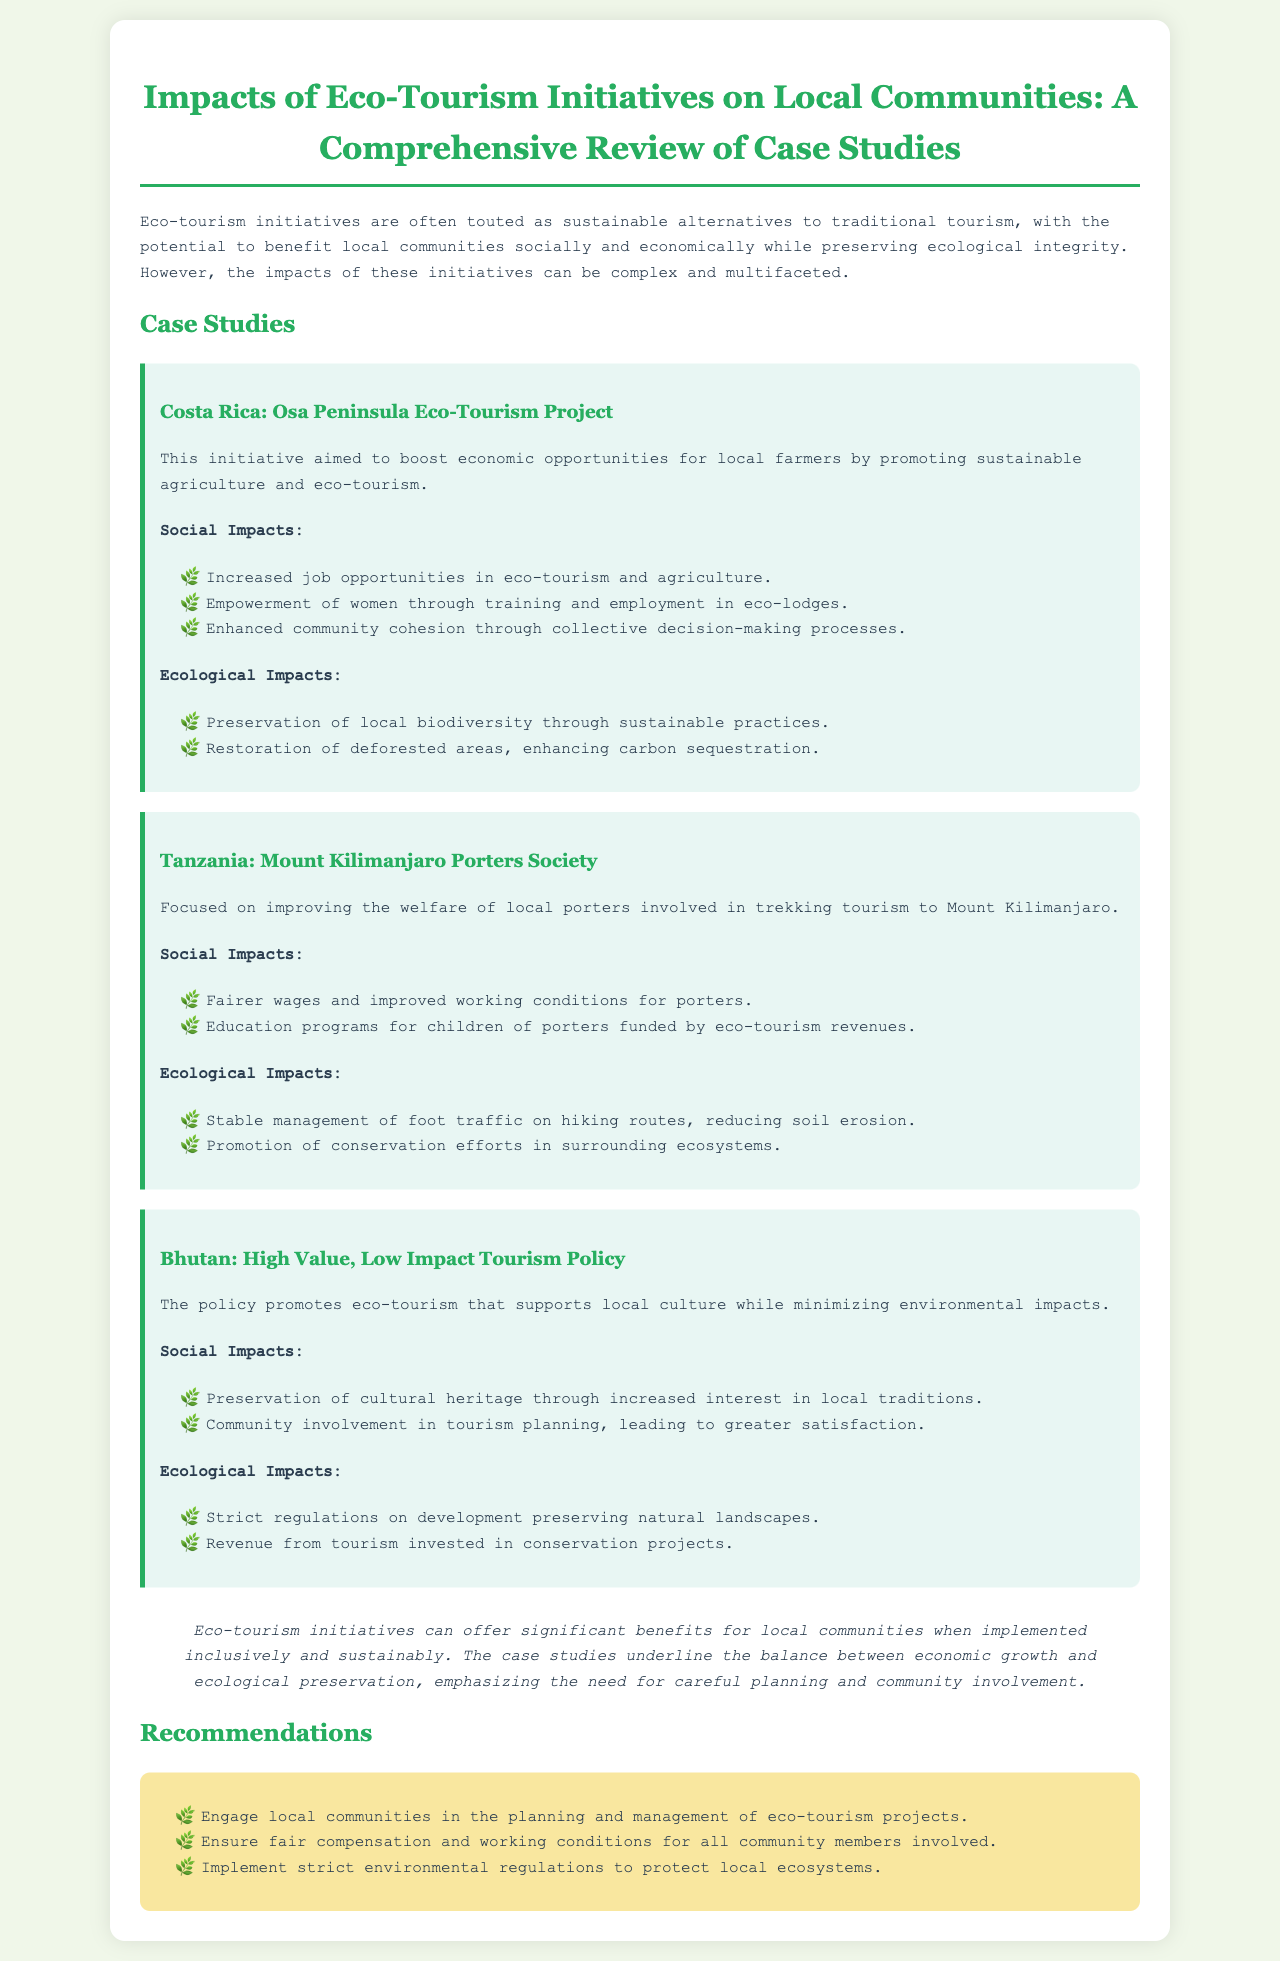what is the title of the report? The title of the report is highlighted at the top of the document, indicating the focus of the study.
Answer: Impacts of Eco-Tourism Initiatives on Local Communities: A Comprehensive Review of Case Studies how many case studies are presented in the document? The document includes a section titled "Case Studies" which outlines several specific examples.
Answer: Three which project is focused on local porters? The document specifies a case study that addresses the welfare of local porters involved in tourism activities.
Answer: Mount Kilimanjaro Porters Society what are the ecological impacts listed for Costa Rica's initiative? The document provides a section under Costa Rica's case study detailing its ecological contributions.
Answer: Preservation of local biodiversity through sustainable practices; Restoration of deforested areas, enhancing carbon sequestration what recommendation emphasizes community engagement? There is a recommendations section that outlines key actions for ensuring the success of eco-tourism projects, including one about community involvement.
Answer: Engage local communities in the planning and management of eco-tourism projects 